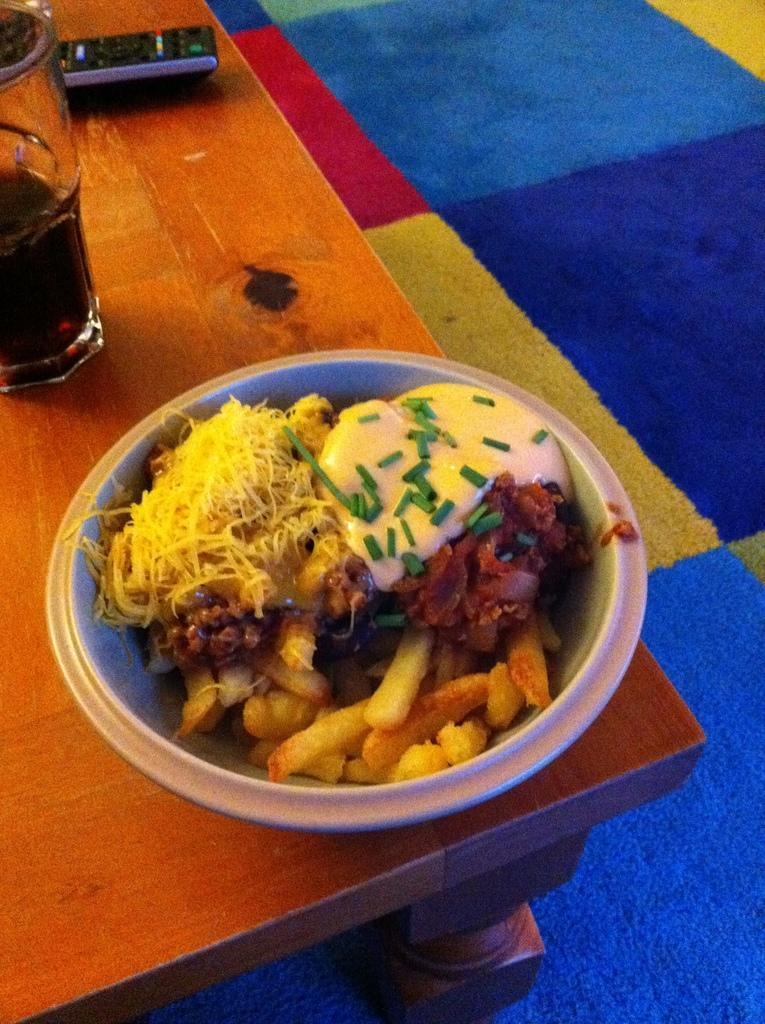What piece of furniture is present in the image? There is a table in the image. What is on the table? There is a serving bowl with food and a beverage bottle on the table. What object related to entertainment can be seen on the table? There is a remote on the table. What can be seen in the background of the image? There is a carpet visible in the background of the image. What type of toys are scattered on the carpet in the image? There are no toys present in the image; the carpet is visible in the background, but no toys are mentioned in the facts provided. 